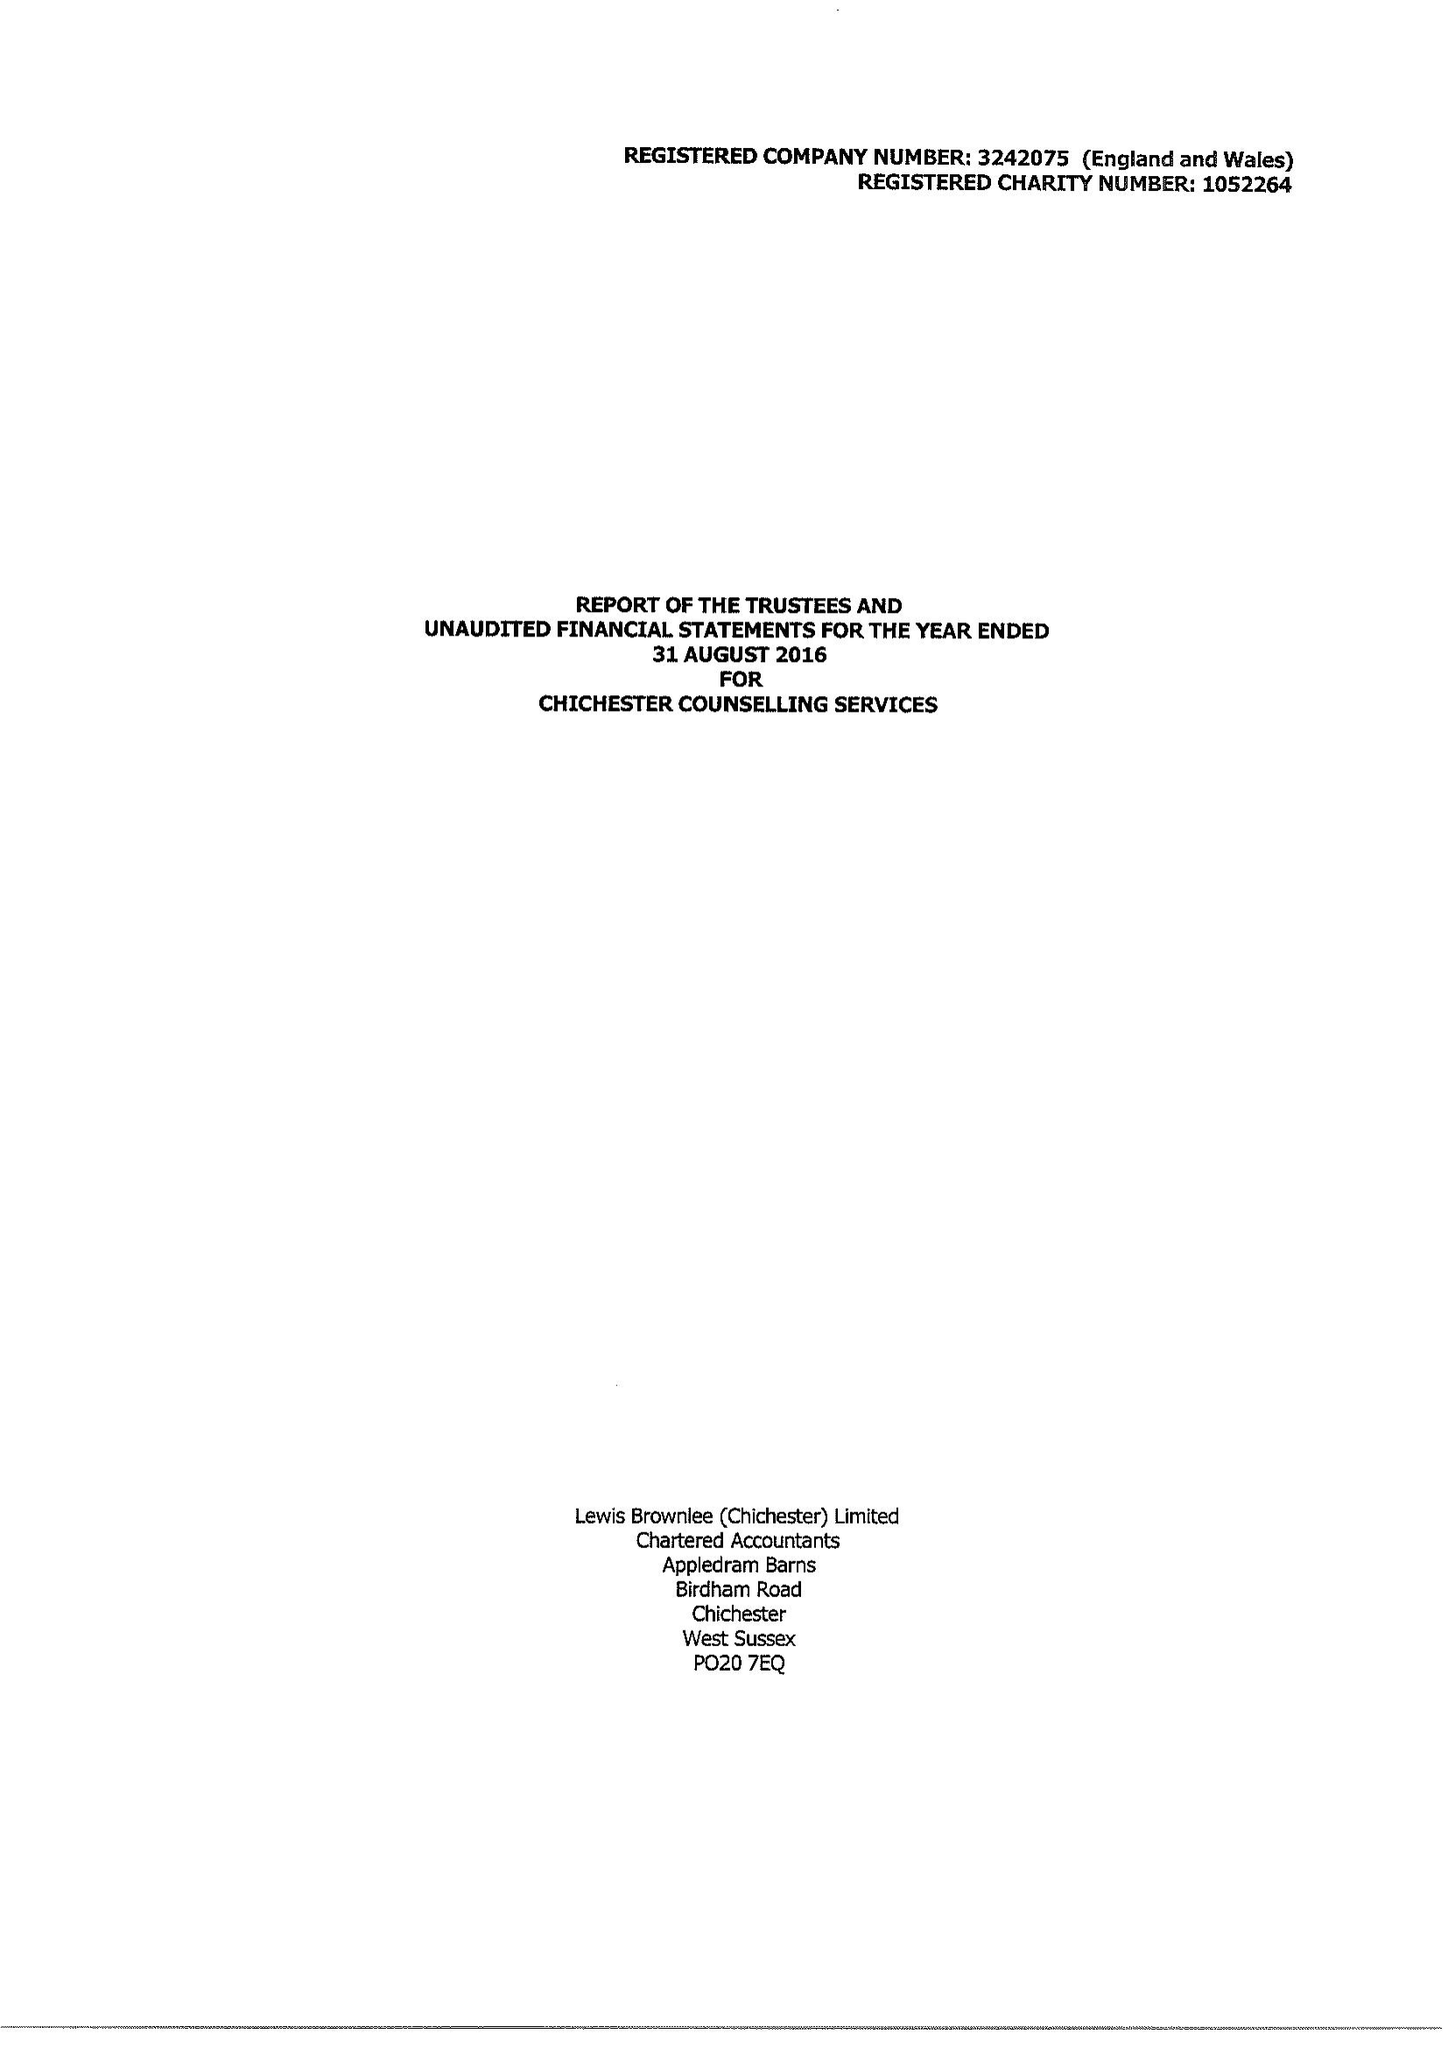What is the value for the income_annually_in_british_pounds?
Answer the question using a single word or phrase. 175256.00 